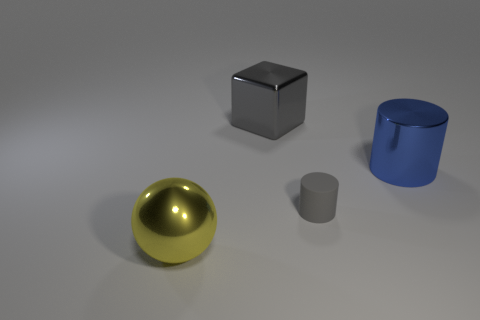Add 1 large yellow objects. How many objects exist? 5 Subtract all balls. How many objects are left? 3 Add 2 large spheres. How many large spheres are left? 3 Add 2 big blue cylinders. How many big blue cylinders exist? 3 Subtract 1 yellow balls. How many objects are left? 3 Subtract all small purple rubber things. Subtract all blue objects. How many objects are left? 3 